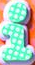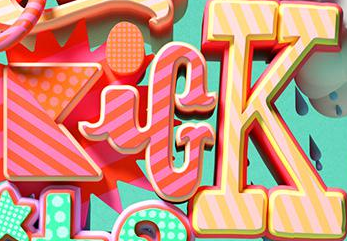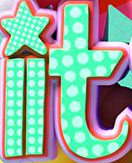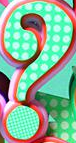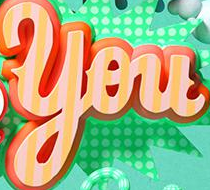What words are shown in these images in order, separated by a semicolon? i; KicK; it; ?; You 